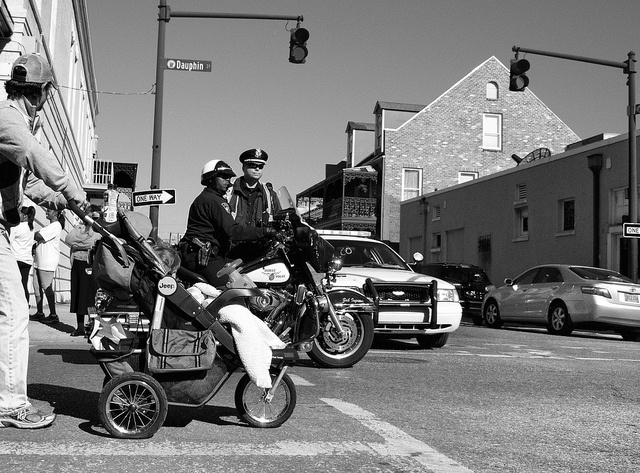Describe the objects in this image and their specific colors. I can see people in lightgray, black, darkgray, and gray tones, motorcycle in lightgray, black, gray, and darkgray tones, car in lightgray, black, white, gray, and darkgray tones, car in lightgray, gray, black, white, and darkgray tones, and people in lightgray, black, gray, and darkgray tones in this image. 